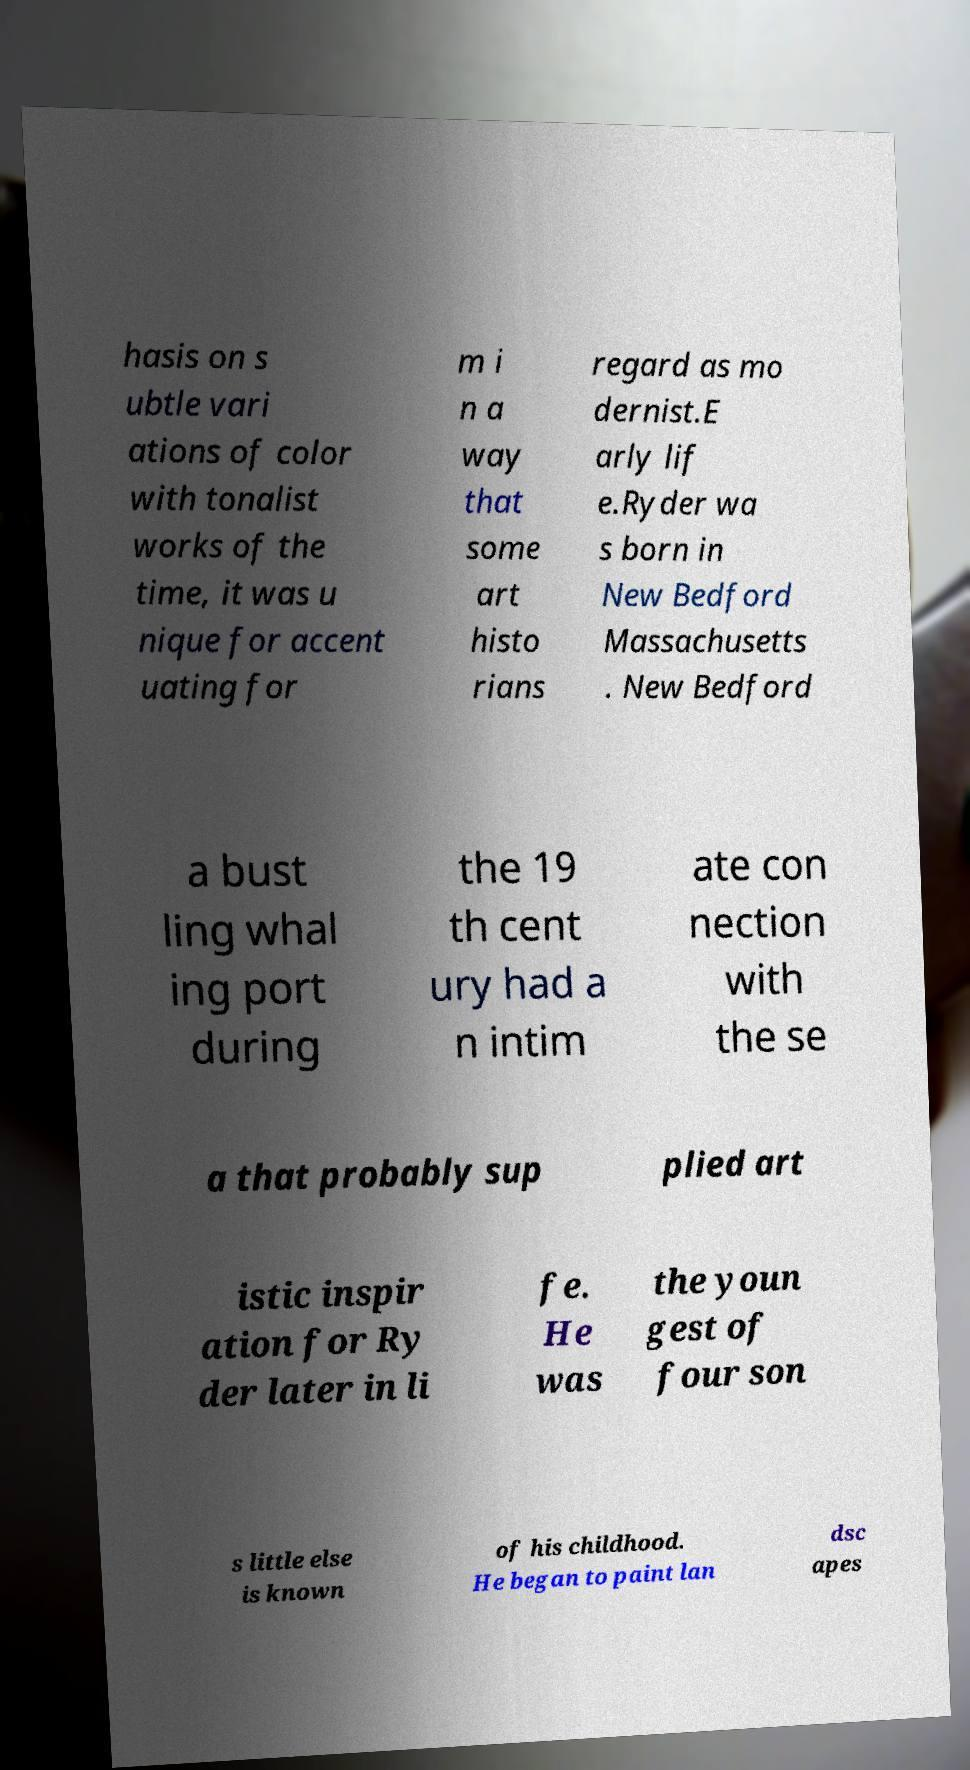There's text embedded in this image that I need extracted. Can you transcribe it verbatim? hasis on s ubtle vari ations of color with tonalist works of the time, it was u nique for accent uating for m i n a way that some art histo rians regard as mo dernist.E arly lif e.Ryder wa s born in New Bedford Massachusetts . New Bedford a bust ling whal ing port during the 19 th cent ury had a n intim ate con nection with the se a that probably sup plied art istic inspir ation for Ry der later in li fe. He was the youn gest of four son s little else is known of his childhood. He began to paint lan dsc apes 